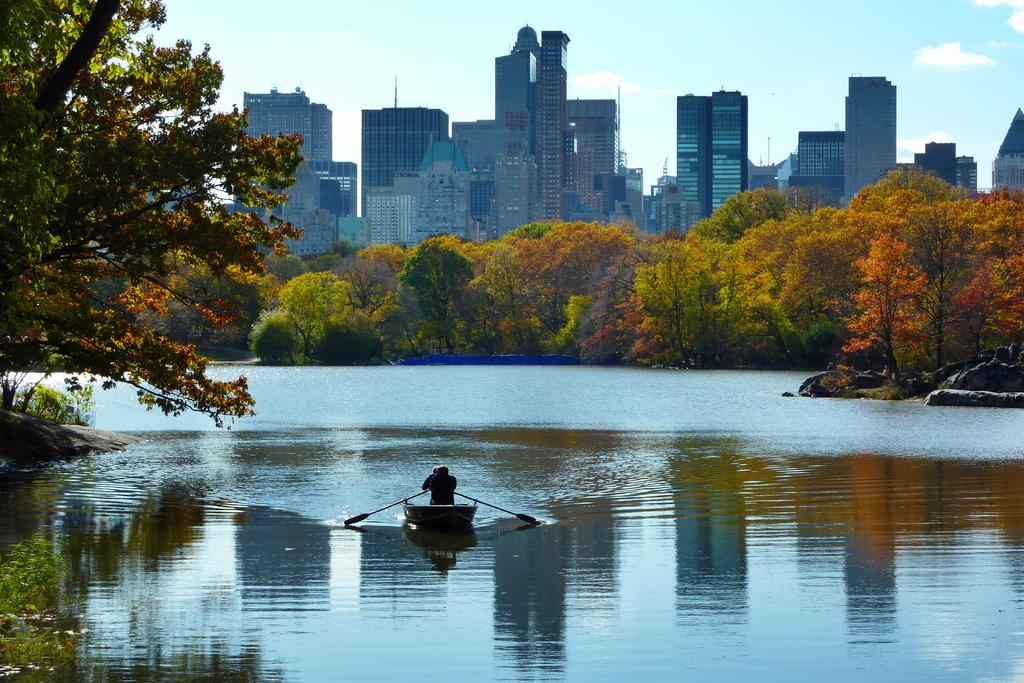What type of structures can be seen in the image? There are buildings in the image. What natural elements are present in the image? There are trees in the image. What is the man in the boat doing? The man is in the boat, which is in the water. How would you describe the sky in the image? The sky is blue and cloudy. Where is the boot located in the image? There is no boot present in the image. What type of achievement is the man in the boat celebrating? There is no indication of any achievement in the image; it simply shows a man in a boat. 